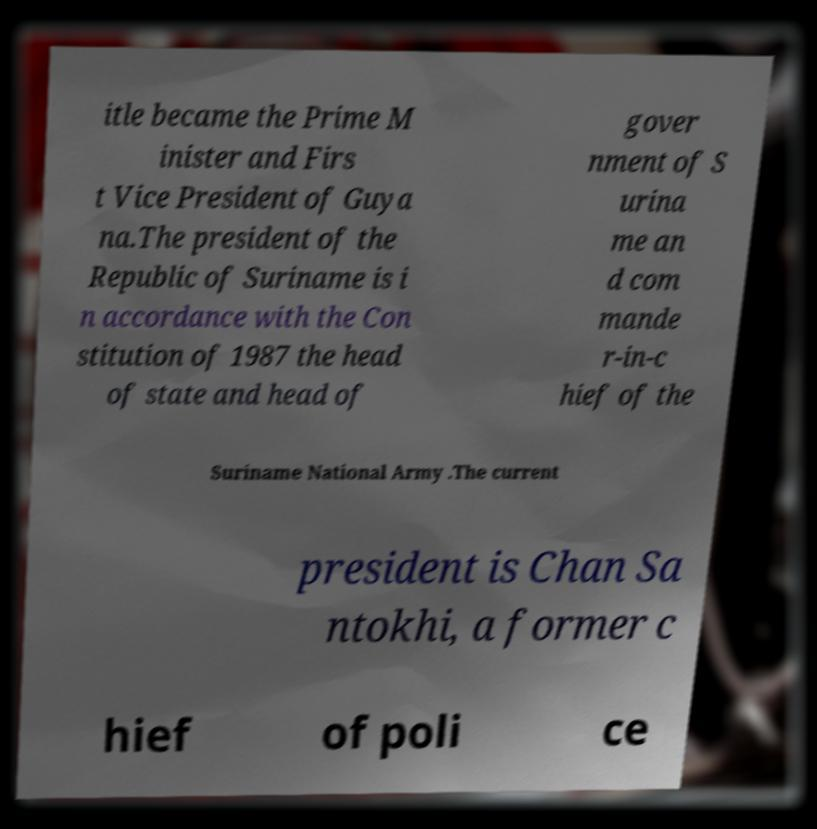For documentation purposes, I need the text within this image transcribed. Could you provide that? itle became the Prime M inister and Firs t Vice President of Guya na.The president of the Republic of Suriname is i n accordance with the Con stitution of 1987 the head of state and head of gover nment of S urina me an d com mande r-in-c hief of the Suriname National Army .The current president is Chan Sa ntokhi, a former c hief of poli ce 